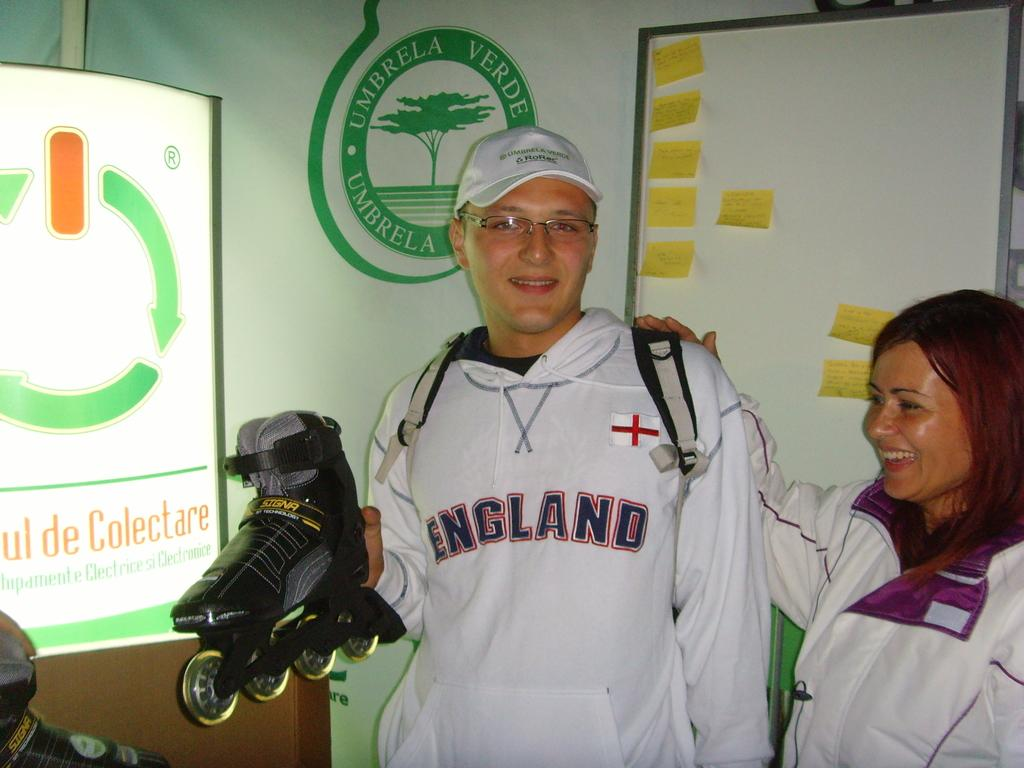<image>
Summarize the visual content of the image. a woman and man in England hoodie standing in front of sign saying Umbrella 